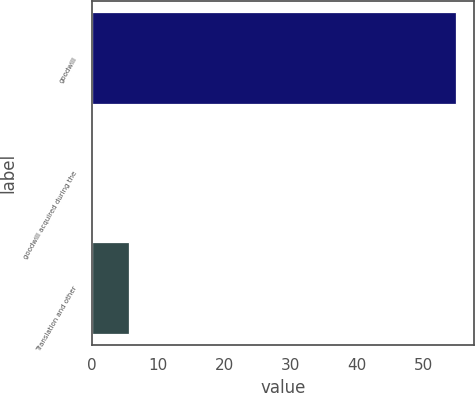Convert chart. <chart><loc_0><loc_0><loc_500><loc_500><bar_chart><fcel>goodwill<fcel>goodwill acquired during the<fcel>Translation and other<nl><fcel>54.9<fcel>0.1<fcel>5.58<nl></chart> 